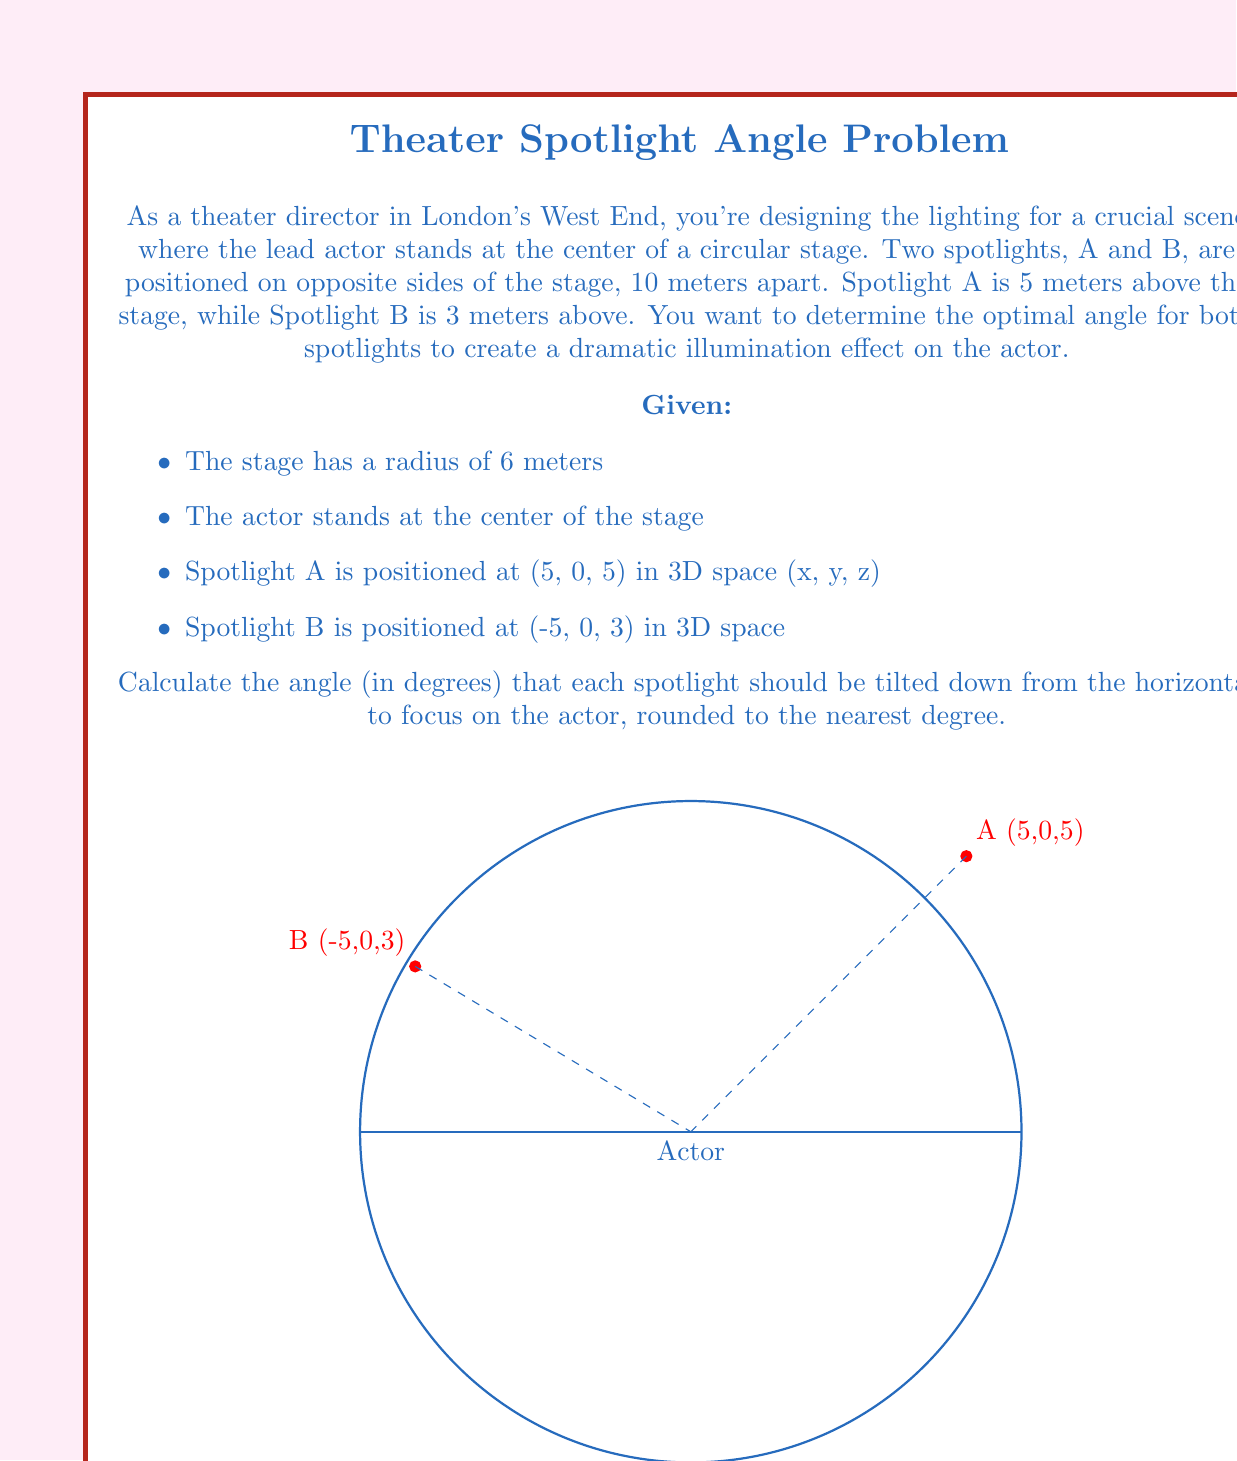Solve this math problem. Let's approach this problem step-by-step using vector calculus and trigonometry:

1) First, let's define the vectors from each spotlight to the actor:

   Vector A to Actor: $\vec{v_A} = (0-5, 0-0, 0-5) = (-5, 0, -5)$
   Vector B to Actor: $\vec{v_B} = (0-(-5), 0-0, 0-3) = (5, 0, -3)$

2) The angle we're looking for is between these vectors and their projections onto the horizontal plane (the stage floor). We can use the dot product to find these angles.

3) For Spotlight A:
   The magnitude of $\vec{v_A}$ is $|\vec{v_A}| = \sqrt{(-5)^2 + 0^2 + (-5)^2} = 5\sqrt{2}$
   The horizontal component has magnitude $\sqrt{(-5)^2 + 0^2} = 5$

   The cosine of the angle is given by:
   $\cos(\theta_A) = \frac{5}{5\sqrt{2}} = \frac{1}{\sqrt{2}}$

   Therefore, $\theta_A = \arccos(\frac{1}{\sqrt{2}})$

4) For Spotlight B:
   The magnitude of $\vec{v_B}$ is $|\vec{v_B}| = \sqrt{5^2 + 0^2 + (-3)^2} = \sqrt{34}$
   The horizontal component has magnitude $5$

   The cosine of the angle is given by:
   $\cos(\theta_B) = \frac{5}{\sqrt{34}}$

   Therefore, $\theta_B = \arccos(\frac{5}{\sqrt{34}})$

5) Converting to degrees and rounding to the nearest degree:

   $\theta_A = \arccos(\frac{1}{\sqrt{2}}) \cdot \frac{180}{\pi} \approx 45°$
   $\theta_B = \arccos(\frac{5}{\sqrt{34}}) \cdot \frac{180}{\pi} \approx 31°$

Thus, Spotlight A should be tilted down 45° from the horizontal, and Spotlight B should be tilted down 31° from the horizontal.
Answer: 45°, 31° 